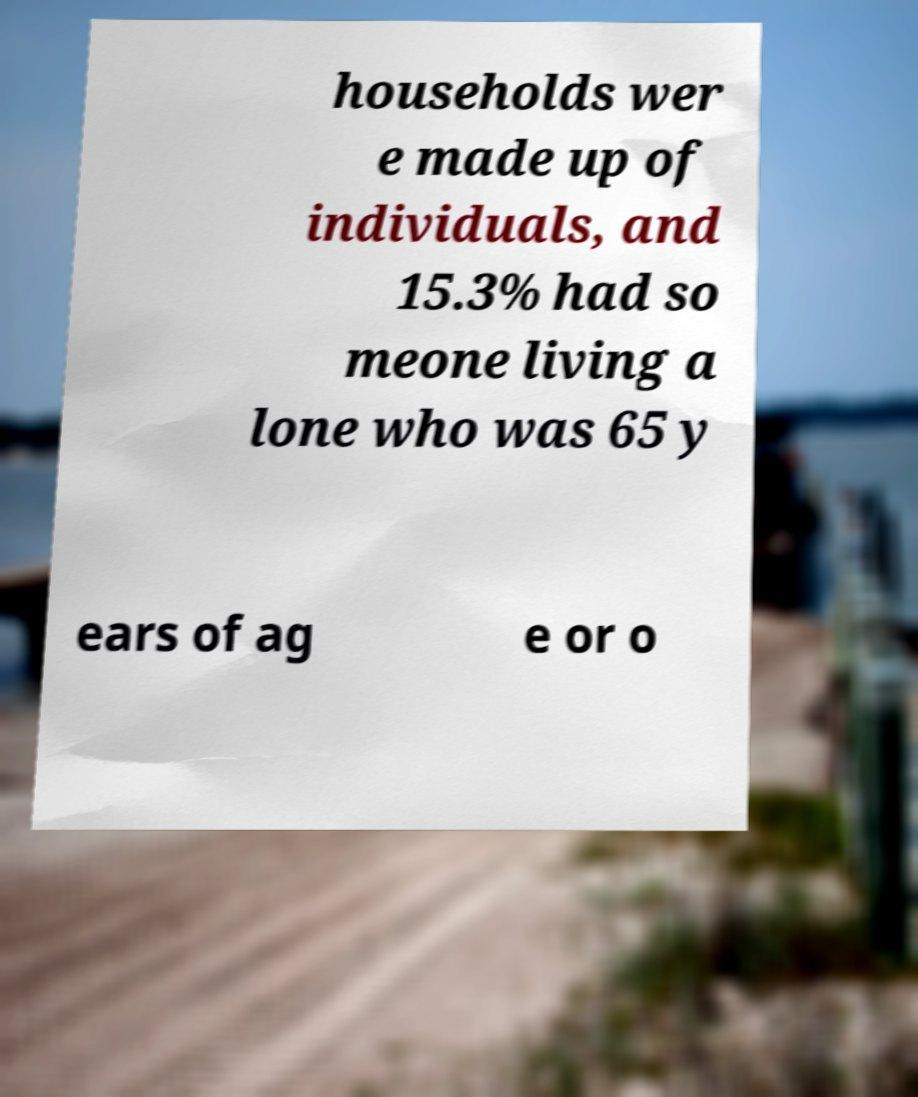What messages or text are displayed in this image? I need them in a readable, typed format. households wer e made up of individuals, and 15.3% had so meone living a lone who was 65 y ears of ag e or o 